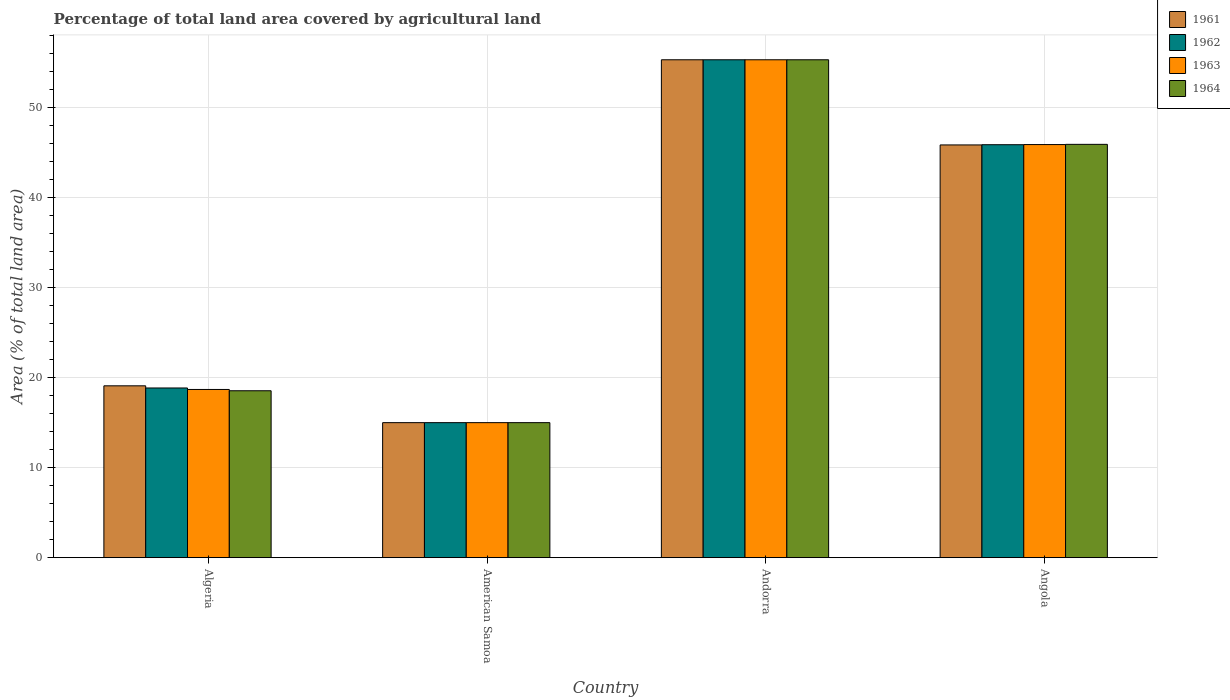Are the number of bars on each tick of the X-axis equal?
Make the answer very short. Yes. How many bars are there on the 4th tick from the right?
Your answer should be very brief. 4. What is the label of the 2nd group of bars from the left?
Offer a terse response. American Samoa. In how many cases, is the number of bars for a given country not equal to the number of legend labels?
Provide a succinct answer. 0. What is the percentage of agricultural land in 1961 in American Samoa?
Make the answer very short. 15. Across all countries, what is the maximum percentage of agricultural land in 1961?
Ensure brevity in your answer.  55.32. Across all countries, what is the minimum percentage of agricultural land in 1963?
Offer a very short reply. 15. In which country was the percentage of agricultural land in 1963 maximum?
Keep it short and to the point. Andorra. In which country was the percentage of agricultural land in 1961 minimum?
Your response must be concise. American Samoa. What is the total percentage of agricultural land in 1961 in the graph?
Offer a very short reply. 135.27. What is the difference between the percentage of agricultural land in 1963 in Andorra and that in Angola?
Keep it short and to the point. 9.42. What is the difference between the percentage of agricultural land in 1964 in Angola and the percentage of agricultural land in 1963 in American Samoa?
Provide a short and direct response. 30.92. What is the average percentage of agricultural land in 1964 per country?
Keep it short and to the point. 33.7. In how many countries, is the percentage of agricultural land in 1964 greater than 34 %?
Your response must be concise. 2. What is the ratio of the percentage of agricultural land in 1964 in Algeria to that in American Samoa?
Make the answer very short. 1.24. Is the percentage of agricultural land in 1961 in American Samoa less than that in Angola?
Your answer should be very brief. Yes. What is the difference between the highest and the second highest percentage of agricultural land in 1961?
Ensure brevity in your answer.  -26.77. What is the difference between the highest and the lowest percentage of agricultural land in 1962?
Offer a terse response. 40.32. In how many countries, is the percentage of agricultural land in 1964 greater than the average percentage of agricultural land in 1964 taken over all countries?
Your response must be concise. 2. What does the 2nd bar from the left in Algeria represents?
Provide a succinct answer. 1962. What does the 3rd bar from the right in Andorra represents?
Provide a short and direct response. 1962. How many bars are there?
Offer a very short reply. 16. Are all the bars in the graph horizontal?
Offer a very short reply. No. What is the difference between two consecutive major ticks on the Y-axis?
Offer a terse response. 10. Does the graph contain any zero values?
Your answer should be compact. No. Does the graph contain grids?
Provide a short and direct response. Yes. Where does the legend appear in the graph?
Ensure brevity in your answer.  Top right. What is the title of the graph?
Ensure brevity in your answer.  Percentage of total land area covered by agricultural land. Does "1980" appear as one of the legend labels in the graph?
Give a very brief answer. No. What is the label or title of the Y-axis?
Your response must be concise. Area (% of total land area). What is the Area (% of total land area) in 1961 in Algeria?
Your answer should be compact. 19.09. What is the Area (% of total land area) in 1962 in Algeria?
Provide a succinct answer. 18.85. What is the Area (% of total land area) in 1963 in Algeria?
Ensure brevity in your answer.  18.69. What is the Area (% of total land area) of 1964 in Algeria?
Keep it short and to the point. 18.54. What is the Area (% of total land area) in 1961 in American Samoa?
Make the answer very short. 15. What is the Area (% of total land area) in 1962 in American Samoa?
Your response must be concise. 15. What is the Area (% of total land area) in 1963 in American Samoa?
Offer a terse response. 15. What is the Area (% of total land area) in 1961 in Andorra?
Offer a very short reply. 55.32. What is the Area (% of total land area) in 1962 in Andorra?
Your answer should be compact. 55.32. What is the Area (% of total land area) of 1963 in Andorra?
Offer a terse response. 55.32. What is the Area (% of total land area) in 1964 in Andorra?
Your answer should be very brief. 55.32. What is the Area (% of total land area) in 1961 in Angola?
Make the answer very short. 45.86. What is the Area (% of total land area) of 1962 in Angola?
Your answer should be compact. 45.88. What is the Area (% of total land area) of 1963 in Angola?
Make the answer very short. 45.9. What is the Area (% of total land area) in 1964 in Angola?
Ensure brevity in your answer.  45.92. Across all countries, what is the maximum Area (% of total land area) of 1961?
Keep it short and to the point. 55.32. Across all countries, what is the maximum Area (% of total land area) of 1962?
Provide a succinct answer. 55.32. Across all countries, what is the maximum Area (% of total land area) of 1963?
Offer a terse response. 55.32. Across all countries, what is the maximum Area (% of total land area) of 1964?
Your answer should be compact. 55.32. Across all countries, what is the minimum Area (% of total land area) of 1962?
Provide a succinct answer. 15. Across all countries, what is the minimum Area (% of total land area) in 1963?
Give a very brief answer. 15. Across all countries, what is the minimum Area (% of total land area) in 1964?
Give a very brief answer. 15. What is the total Area (% of total land area) in 1961 in the graph?
Your response must be concise. 135.27. What is the total Area (% of total land area) in 1962 in the graph?
Offer a terse response. 135.05. What is the total Area (% of total land area) of 1963 in the graph?
Provide a short and direct response. 134.9. What is the total Area (% of total land area) in 1964 in the graph?
Your response must be concise. 134.78. What is the difference between the Area (% of total land area) of 1961 in Algeria and that in American Samoa?
Keep it short and to the point. 4.09. What is the difference between the Area (% of total land area) of 1962 in Algeria and that in American Samoa?
Provide a short and direct response. 3.85. What is the difference between the Area (% of total land area) of 1963 in Algeria and that in American Samoa?
Provide a short and direct response. 3.69. What is the difference between the Area (% of total land area) in 1964 in Algeria and that in American Samoa?
Keep it short and to the point. 3.54. What is the difference between the Area (% of total land area) of 1961 in Algeria and that in Andorra?
Your response must be concise. -36.23. What is the difference between the Area (% of total land area) in 1962 in Algeria and that in Andorra?
Make the answer very short. -36.47. What is the difference between the Area (% of total land area) in 1963 in Algeria and that in Andorra?
Provide a succinct answer. -36.63. What is the difference between the Area (% of total land area) of 1964 in Algeria and that in Andorra?
Provide a succinct answer. -36.78. What is the difference between the Area (% of total land area) in 1961 in Algeria and that in Angola?
Your answer should be compact. -26.77. What is the difference between the Area (% of total land area) in 1962 in Algeria and that in Angola?
Your answer should be very brief. -27.03. What is the difference between the Area (% of total land area) of 1963 in Algeria and that in Angola?
Your answer should be very brief. -27.21. What is the difference between the Area (% of total land area) of 1964 in Algeria and that in Angola?
Provide a succinct answer. -27.38. What is the difference between the Area (% of total land area) of 1961 in American Samoa and that in Andorra?
Offer a terse response. -40.32. What is the difference between the Area (% of total land area) of 1962 in American Samoa and that in Andorra?
Offer a very short reply. -40.32. What is the difference between the Area (% of total land area) of 1963 in American Samoa and that in Andorra?
Provide a short and direct response. -40.32. What is the difference between the Area (% of total land area) in 1964 in American Samoa and that in Andorra?
Offer a very short reply. -40.32. What is the difference between the Area (% of total land area) of 1961 in American Samoa and that in Angola?
Your answer should be very brief. -30.86. What is the difference between the Area (% of total land area) of 1962 in American Samoa and that in Angola?
Ensure brevity in your answer.  -30.88. What is the difference between the Area (% of total land area) in 1963 in American Samoa and that in Angola?
Offer a very short reply. -30.9. What is the difference between the Area (% of total land area) of 1964 in American Samoa and that in Angola?
Offer a very short reply. -30.92. What is the difference between the Area (% of total land area) of 1961 in Andorra and that in Angola?
Offer a terse response. 9.46. What is the difference between the Area (% of total land area) of 1962 in Andorra and that in Angola?
Provide a short and direct response. 9.44. What is the difference between the Area (% of total land area) of 1963 in Andorra and that in Angola?
Your answer should be very brief. 9.42. What is the difference between the Area (% of total land area) of 1964 in Andorra and that in Angola?
Your response must be concise. 9.4. What is the difference between the Area (% of total land area) in 1961 in Algeria and the Area (% of total land area) in 1962 in American Samoa?
Offer a very short reply. 4.09. What is the difference between the Area (% of total land area) of 1961 in Algeria and the Area (% of total land area) of 1963 in American Samoa?
Give a very brief answer. 4.09. What is the difference between the Area (% of total land area) in 1961 in Algeria and the Area (% of total land area) in 1964 in American Samoa?
Make the answer very short. 4.09. What is the difference between the Area (% of total land area) in 1962 in Algeria and the Area (% of total land area) in 1963 in American Samoa?
Your answer should be very brief. 3.85. What is the difference between the Area (% of total land area) in 1962 in Algeria and the Area (% of total land area) in 1964 in American Samoa?
Offer a terse response. 3.85. What is the difference between the Area (% of total land area) in 1963 in Algeria and the Area (% of total land area) in 1964 in American Samoa?
Offer a very short reply. 3.69. What is the difference between the Area (% of total land area) in 1961 in Algeria and the Area (% of total land area) in 1962 in Andorra?
Your answer should be compact. -36.23. What is the difference between the Area (% of total land area) in 1961 in Algeria and the Area (% of total land area) in 1963 in Andorra?
Your response must be concise. -36.23. What is the difference between the Area (% of total land area) in 1961 in Algeria and the Area (% of total land area) in 1964 in Andorra?
Provide a succinct answer. -36.23. What is the difference between the Area (% of total land area) of 1962 in Algeria and the Area (% of total land area) of 1963 in Andorra?
Your response must be concise. -36.47. What is the difference between the Area (% of total land area) of 1962 in Algeria and the Area (% of total land area) of 1964 in Andorra?
Make the answer very short. -36.47. What is the difference between the Area (% of total land area) of 1963 in Algeria and the Area (% of total land area) of 1964 in Andorra?
Your answer should be very brief. -36.63. What is the difference between the Area (% of total land area) in 1961 in Algeria and the Area (% of total land area) in 1962 in Angola?
Keep it short and to the point. -26.79. What is the difference between the Area (% of total land area) in 1961 in Algeria and the Area (% of total land area) in 1963 in Angola?
Keep it short and to the point. -26.81. What is the difference between the Area (% of total land area) of 1961 in Algeria and the Area (% of total land area) of 1964 in Angola?
Make the answer very short. -26.83. What is the difference between the Area (% of total land area) in 1962 in Algeria and the Area (% of total land area) in 1963 in Angola?
Your answer should be compact. -27.05. What is the difference between the Area (% of total land area) in 1962 in Algeria and the Area (% of total land area) in 1964 in Angola?
Give a very brief answer. -27.07. What is the difference between the Area (% of total land area) of 1963 in Algeria and the Area (% of total land area) of 1964 in Angola?
Offer a very short reply. -27.23. What is the difference between the Area (% of total land area) in 1961 in American Samoa and the Area (% of total land area) in 1962 in Andorra?
Ensure brevity in your answer.  -40.32. What is the difference between the Area (% of total land area) of 1961 in American Samoa and the Area (% of total land area) of 1963 in Andorra?
Offer a very short reply. -40.32. What is the difference between the Area (% of total land area) in 1961 in American Samoa and the Area (% of total land area) in 1964 in Andorra?
Offer a very short reply. -40.32. What is the difference between the Area (% of total land area) in 1962 in American Samoa and the Area (% of total land area) in 1963 in Andorra?
Keep it short and to the point. -40.32. What is the difference between the Area (% of total land area) in 1962 in American Samoa and the Area (% of total land area) in 1964 in Andorra?
Ensure brevity in your answer.  -40.32. What is the difference between the Area (% of total land area) of 1963 in American Samoa and the Area (% of total land area) of 1964 in Andorra?
Your response must be concise. -40.32. What is the difference between the Area (% of total land area) in 1961 in American Samoa and the Area (% of total land area) in 1962 in Angola?
Your answer should be compact. -30.88. What is the difference between the Area (% of total land area) in 1961 in American Samoa and the Area (% of total land area) in 1963 in Angola?
Offer a terse response. -30.9. What is the difference between the Area (% of total land area) of 1961 in American Samoa and the Area (% of total land area) of 1964 in Angola?
Give a very brief answer. -30.92. What is the difference between the Area (% of total land area) in 1962 in American Samoa and the Area (% of total land area) in 1963 in Angola?
Your answer should be very brief. -30.9. What is the difference between the Area (% of total land area) in 1962 in American Samoa and the Area (% of total land area) in 1964 in Angola?
Offer a very short reply. -30.92. What is the difference between the Area (% of total land area) of 1963 in American Samoa and the Area (% of total land area) of 1964 in Angola?
Your response must be concise. -30.92. What is the difference between the Area (% of total land area) in 1961 in Andorra and the Area (% of total land area) in 1962 in Angola?
Provide a succinct answer. 9.44. What is the difference between the Area (% of total land area) in 1961 in Andorra and the Area (% of total land area) in 1963 in Angola?
Your response must be concise. 9.42. What is the difference between the Area (% of total land area) in 1961 in Andorra and the Area (% of total land area) in 1964 in Angola?
Offer a terse response. 9.4. What is the difference between the Area (% of total land area) in 1962 in Andorra and the Area (% of total land area) in 1963 in Angola?
Your answer should be compact. 9.42. What is the difference between the Area (% of total land area) of 1962 in Andorra and the Area (% of total land area) of 1964 in Angola?
Offer a very short reply. 9.4. What is the difference between the Area (% of total land area) in 1963 in Andorra and the Area (% of total land area) in 1964 in Angola?
Provide a short and direct response. 9.4. What is the average Area (% of total land area) in 1961 per country?
Offer a very short reply. 33.82. What is the average Area (% of total land area) in 1962 per country?
Provide a succinct answer. 33.76. What is the average Area (% of total land area) of 1963 per country?
Give a very brief answer. 33.73. What is the average Area (% of total land area) of 1964 per country?
Your answer should be compact. 33.7. What is the difference between the Area (% of total land area) in 1961 and Area (% of total land area) in 1962 in Algeria?
Your response must be concise. 0.24. What is the difference between the Area (% of total land area) in 1961 and Area (% of total land area) in 1963 in Algeria?
Give a very brief answer. 0.4. What is the difference between the Area (% of total land area) of 1961 and Area (% of total land area) of 1964 in Algeria?
Offer a very short reply. 0.55. What is the difference between the Area (% of total land area) of 1962 and Area (% of total land area) of 1963 in Algeria?
Offer a very short reply. 0.16. What is the difference between the Area (% of total land area) of 1962 and Area (% of total land area) of 1964 in Algeria?
Provide a short and direct response. 0.31. What is the difference between the Area (% of total land area) of 1963 and Area (% of total land area) of 1964 in Algeria?
Provide a succinct answer. 0.15. What is the difference between the Area (% of total land area) in 1961 and Area (% of total land area) in 1962 in American Samoa?
Your answer should be compact. 0. What is the difference between the Area (% of total land area) of 1961 and Area (% of total land area) of 1963 in American Samoa?
Your response must be concise. 0. What is the difference between the Area (% of total land area) of 1961 and Area (% of total land area) of 1964 in American Samoa?
Keep it short and to the point. 0. What is the difference between the Area (% of total land area) of 1962 and Area (% of total land area) of 1963 in American Samoa?
Provide a succinct answer. 0. What is the difference between the Area (% of total land area) in 1961 and Area (% of total land area) in 1962 in Andorra?
Ensure brevity in your answer.  0. What is the difference between the Area (% of total land area) in 1962 and Area (% of total land area) in 1963 in Andorra?
Your answer should be very brief. 0. What is the difference between the Area (% of total land area) in 1963 and Area (% of total land area) in 1964 in Andorra?
Your response must be concise. 0. What is the difference between the Area (% of total land area) of 1961 and Area (% of total land area) of 1962 in Angola?
Your answer should be very brief. -0.02. What is the difference between the Area (% of total land area) in 1961 and Area (% of total land area) in 1963 in Angola?
Offer a terse response. -0.04. What is the difference between the Area (% of total land area) in 1961 and Area (% of total land area) in 1964 in Angola?
Your answer should be very brief. -0.06. What is the difference between the Area (% of total land area) in 1962 and Area (% of total land area) in 1963 in Angola?
Your answer should be very brief. -0.02. What is the difference between the Area (% of total land area) of 1962 and Area (% of total land area) of 1964 in Angola?
Offer a terse response. -0.04. What is the difference between the Area (% of total land area) in 1963 and Area (% of total land area) in 1964 in Angola?
Provide a succinct answer. -0.02. What is the ratio of the Area (% of total land area) of 1961 in Algeria to that in American Samoa?
Keep it short and to the point. 1.27. What is the ratio of the Area (% of total land area) in 1962 in Algeria to that in American Samoa?
Make the answer very short. 1.26. What is the ratio of the Area (% of total land area) of 1963 in Algeria to that in American Samoa?
Offer a very short reply. 1.25. What is the ratio of the Area (% of total land area) in 1964 in Algeria to that in American Samoa?
Offer a terse response. 1.24. What is the ratio of the Area (% of total land area) in 1961 in Algeria to that in Andorra?
Your answer should be very brief. 0.35. What is the ratio of the Area (% of total land area) in 1962 in Algeria to that in Andorra?
Provide a succinct answer. 0.34. What is the ratio of the Area (% of total land area) of 1963 in Algeria to that in Andorra?
Offer a terse response. 0.34. What is the ratio of the Area (% of total land area) in 1964 in Algeria to that in Andorra?
Your answer should be very brief. 0.34. What is the ratio of the Area (% of total land area) of 1961 in Algeria to that in Angola?
Ensure brevity in your answer.  0.42. What is the ratio of the Area (% of total land area) in 1962 in Algeria to that in Angola?
Give a very brief answer. 0.41. What is the ratio of the Area (% of total land area) of 1963 in Algeria to that in Angola?
Offer a terse response. 0.41. What is the ratio of the Area (% of total land area) in 1964 in Algeria to that in Angola?
Make the answer very short. 0.4. What is the ratio of the Area (% of total land area) of 1961 in American Samoa to that in Andorra?
Give a very brief answer. 0.27. What is the ratio of the Area (% of total land area) of 1962 in American Samoa to that in Andorra?
Your answer should be very brief. 0.27. What is the ratio of the Area (% of total land area) of 1963 in American Samoa to that in Andorra?
Offer a terse response. 0.27. What is the ratio of the Area (% of total land area) in 1964 in American Samoa to that in Andorra?
Offer a very short reply. 0.27. What is the ratio of the Area (% of total land area) in 1961 in American Samoa to that in Angola?
Your answer should be very brief. 0.33. What is the ratio of the Area (% of total land area) of 1962 in American Samoa to that in Angola?
Your answer should be very brief. 0.33. What is the ratio of the Area (% of total land area) of 1963 in American Samoa to that in Angola?
Your answer should be very brief. 0.33. What is the ratio of the Area (% of total land area) in 1964 in American Samoa to that in Angola?
Give a very brief answer. 0.33. What is the ratio of the Area (% of total land area) of 1961 in Andorra to that in Angola?
Offer a very short reply. 1.21. What is the ratio of the Area (% of total land area) of 1962 in Andorra to that in Angola?
Your answer should be very brief. 1.21. What is the ratio of the Area (% of total land area) of 1963 in Andorra to that in Angola?
Your answer should be compact. 1.21. What is the ratio of the Area (% of total land area) in 1964 in Andorra to that in Angola?
Make the answer very short. 1.2. What is the difference between the highest and the second highest Area (% of total land area) in 1961?
Your answer should be compact. 9.46. What is the difference between the highest and the second highest Area (% of total land area) of 1962?
Keep it short and to the point. 9.44. What is the difference between the highest and the second highest Area (% of total land area) in 1963?
Make the answer very short. 9.42. What is the difference between the highest and the second highest Area (% of total land area) in 1964?
Your answer should be very brief. 9.4. What is the difference between the highest and the lowest Area (% of total land area) in 1961?
Offer a very short reply. 40.32. What is the difference between the highest and the lowest Area (% of total land area) in 1962?
Keep it short and to the point. 40.32. What is the difference between the highest and the lowest Area (% of total land area) in 1963?
Your answer should be compact. 40.32. What is the difference between the highest and the lowest Area (% of total land area) in 1964?
Offer a very short reply. 40.32. 